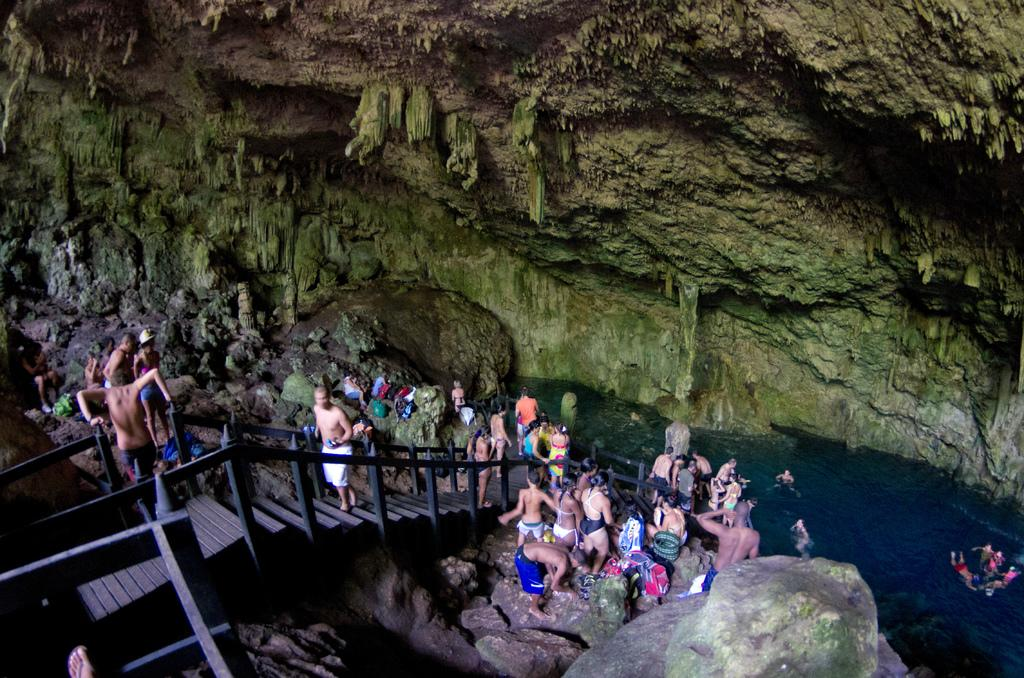What is the main feature of the stone in the image? The stone in the image has green and brown colors. What architectural element can be seen in the image? There are stairs in the image. Can you describe the people in the image? There are people in the image. What other stones are present in the image? There are stones in the image. What natural element is visible in the image? There is water visible in the image. What type of toys are being used by the people in the image? There are no toys visible in the image. How many feet are visible in the image? The number of feet visible in the image cannot be determined from the provided facts. 